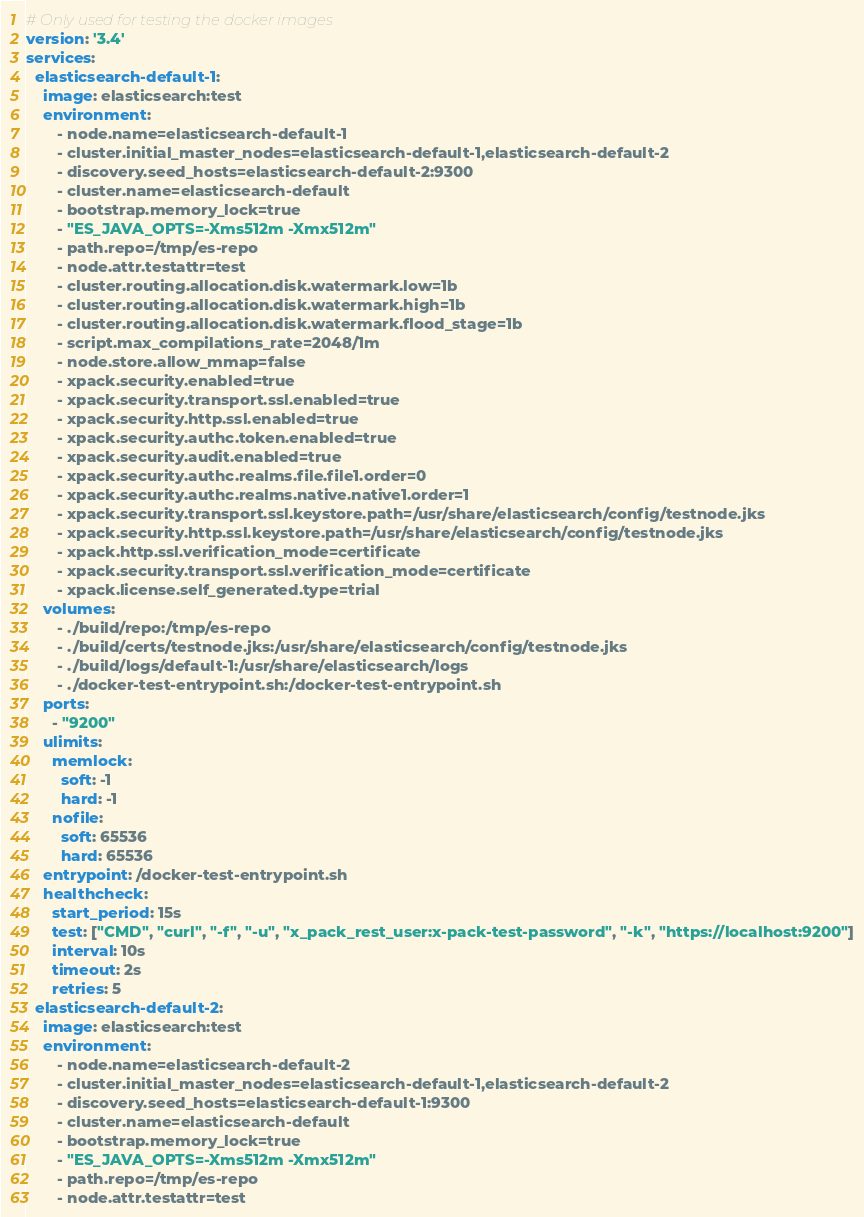Convert code to text. <code><loc_0><loc_0><loc_500><loc_500><_YAML_># Only used for testing the docker images
version: '3.4'
services:
  elasticsearch-default-1:
    image: elasticsearch:test
    environment:
       - node.name=elasticsearch-default-1
       - cluster.initial_master_nodes=elasticsearch-default-1,elasticsearch-default-2
       - discovery.seed_hosts=elasticsearch-default-2:9300
       - cluster.name=elasticsearch-default
       - bootstrap.memory_lock=true
       - "ES_JAVA_OPTS=-Xms512m -Xmx512m"
       - path.repo=/tmp/es-repo
       - node.attr.testattr=test
       - cluster.routing.allocation.disk.watermark.low=1b
       - cluster.routing.allocation.disk.watermark.high=1b
       - cluster.routing.allocation.disk.watermark.flood_stage=1b
       - script.max_compilations_rate=2048/1m
       - node.store.allow_mmap=false
       - xpack.security.enabled=true
       - xpack.security.transport.ssl.enabled=true
       - xpack.security.http.ssl.enabled=true
       - xpack.security.authc.token.enabled=true
       - xpack.security.audit.enabled=true
       - xpack.security.authc.realms.file.file1.order=0
       - xpack.security.authc.realms.native.native1.order=1
       - xpack.security.transport.ssl.keystore.path=/usr/share/elasticsearch/config/testnode.jks
       - xpack.security.http.ssl.keystore.path=/usr/share/elasticsearch/config/testnode.jks
       - xpack.http.ssl.verification_mode=certificate
       - xpack.security.transport.ssl.verification_mode=certificate
       - xpack.license.self_generated.type=trial
    volumes:
       - ./build/repo:/tmp/es-repo
       - ./build/certs/testnode.jks:/usr/share/elasticsearch/config/testnode.jks
       - ./build/logs/default-1:/usr/share/elasticsearch/logs
       - ./docker-test-entrypoint.sh:/docker-test-entrypoint.sh
    ports:
      - "9200"
    ulimits:
      memlock:
        soft: -1
        hard: -1
      nofile:
        soft: 65536
        hard: 65536
    entrypoint: /docker-test-entrypoint.sh
    healthcheck:
      start_period: 15s
      test: ["CMD", "curl", "-f", "-u", "x_pack_rest_user:x-pack-test-password", "-k", "https://localhost:9200"]
      interval: 10s
      timeout: 2s
      retries: 5
  elasticsearch-default-2:
    image: elasticsearch:test
    environment:
       - node.name=elasticsearch-default-2
       - cluster.initial_master_nodes=elasticsearch-default-1,elasticsearch-default-2
       - discovery.seed_hosts=elasticsearch-default-1:9300
       - cluster.name=elasticsearch-default
       - bootstrap.memory_lock=true
       - "ES_JAVA_OPTS=-Xms512m -Xmx512m"
       - path.repo=/tmp/es-repo
       - node.attr.testattr=test</code> 